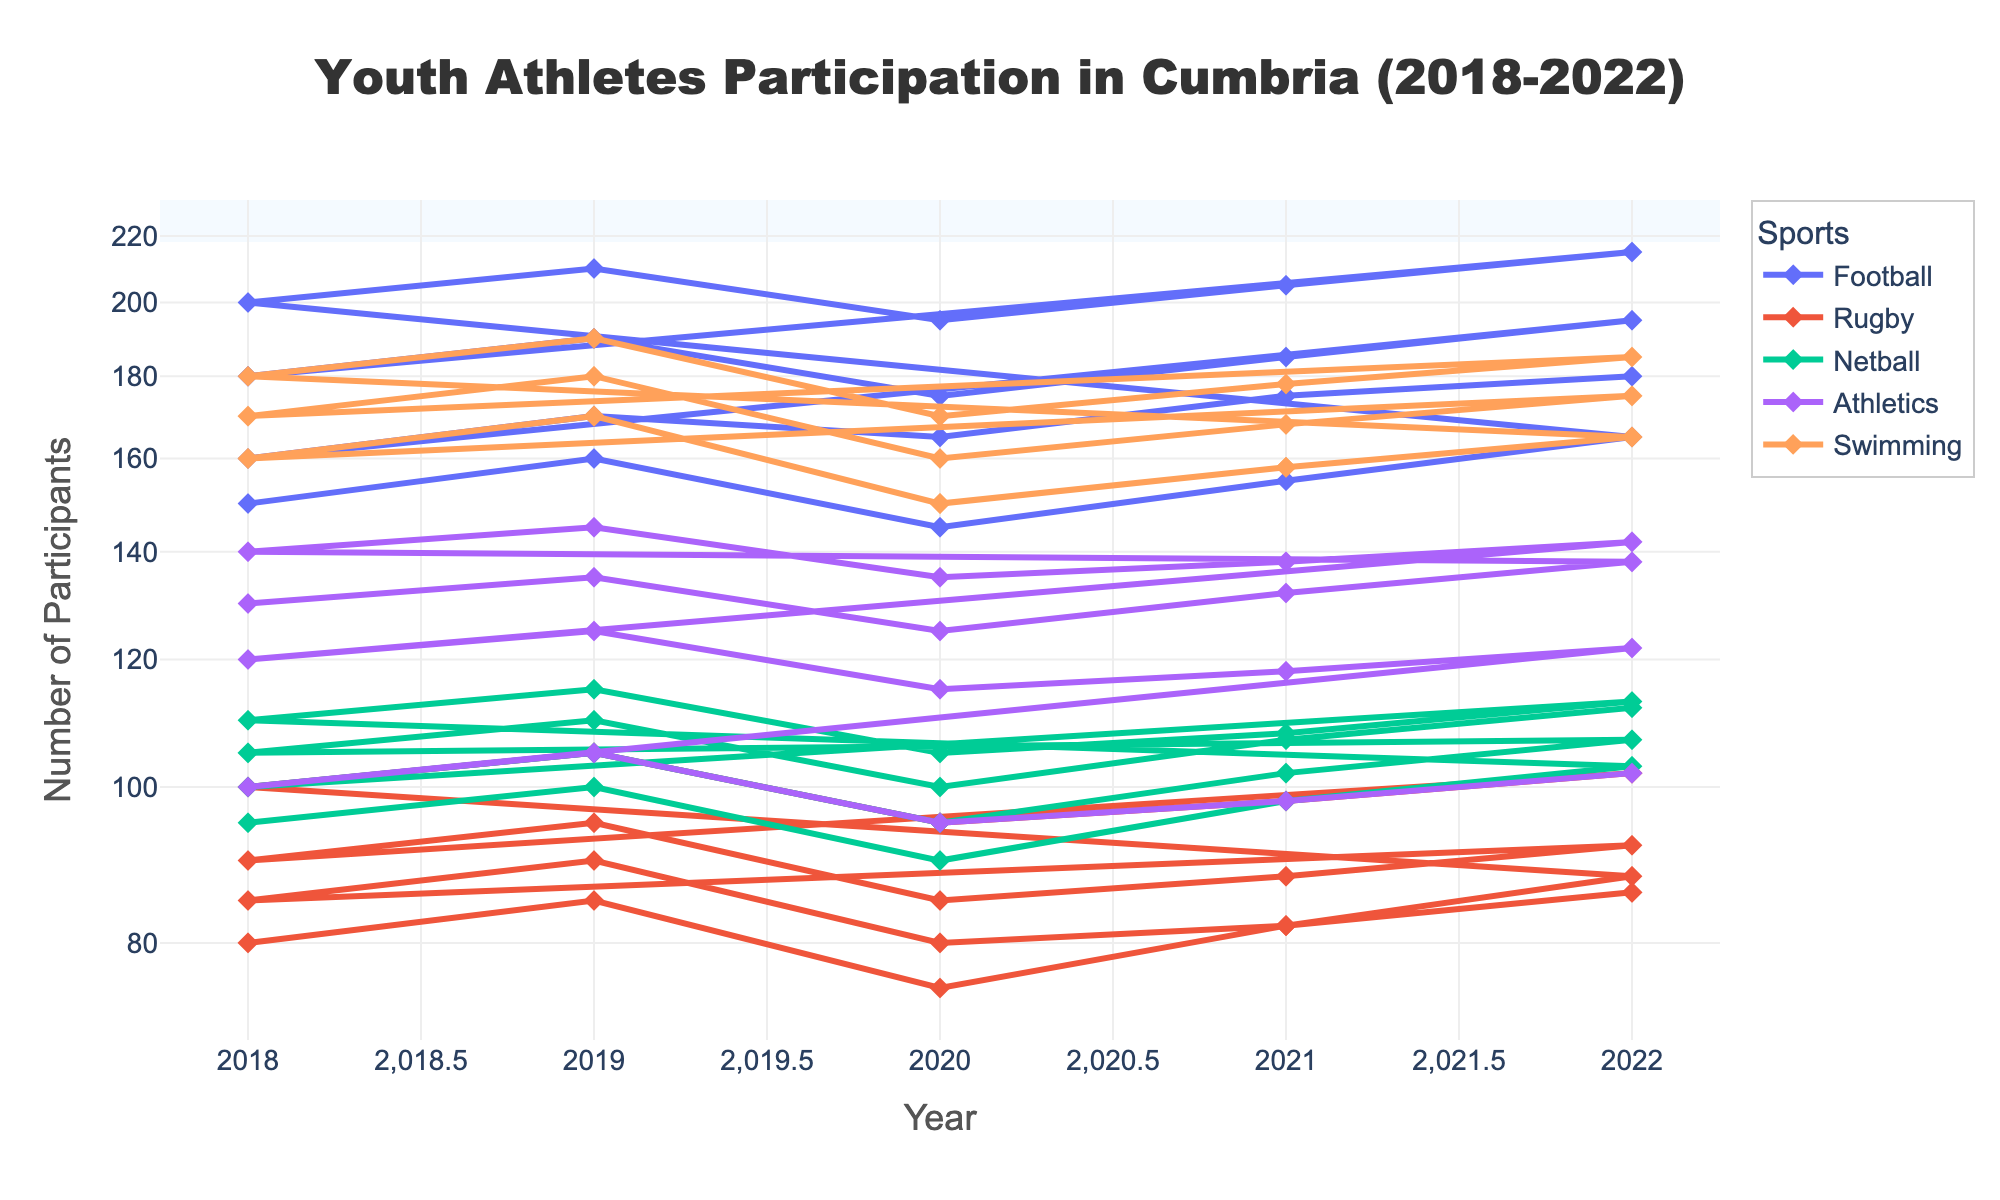What is the title of the figure? The title usually appears at the top of the figure. For this plot, it is intended to provide a summary of the visualized data.
Answer: Youth Athletes Participation in Cumbria (2018-2022) Which sport had the most participants in the "10-12" age group in 2021? Look for the lines representing different sports and focus on the data points for the year 2021 along the x-axis, then identify the highest y-value for the 10-12 age group.
Answer: Football How has the number of participants in athletics for the "16-18" age group changed from 2018 to 2022? Locate the line representing athletics and track its y-values for the "16-18" age group from 2018 to 2022. Compare the starting and ending values.
Answer: Decreased Which sport shows the least variation in participant numbers over the years for the "Under 10" age group? Identify the line for each sport and examine how much the y-values fluctuate for the "Under 10" age group from 2018 to 2022. The sport with the least fluctuation shows the least variation.
Answer: Rugby What is the general trend of participation in netball for the age group "10-12" over the five years? Follow the line representing netball for the "10-12" age group from 2018 to 2022 and observe whether it increases, decreases, or remains stable.
Answer: Increasing In which year did football have the lowest number of participants in the "Under 10" age group? Find the data points for football for the "Under 10" age group for each year and identify the year with the smallest y-value.
Answer: 2020 By how many participants did the "13-15" age group for swimming increase from 2020 to 2022? Look at the data points for swimming in 2020 and 2022 along the y-axis for the "13-15" age group, then subtract the 2020 value from the 2022 value.
Answer: 15 participants Comparing the "10-12" age group, which sport had a higher number of participants in 2020: swimming or rugby? Locate the "10-12" age group data points for swimming and rugby in 2020 and compare their y-values to see which is higher.
Answer: Swimming What is the average number of participants in netball for the "16-18" age group from 2018 to 2022? Sum the y-values for netball for the "16-18" age group from 2018 to 2022 and then divide by the number of years (5).
Answer: 106.8 participants In which age group and year did athletics see a noticeable drop in participation compared to the previous year? Compare y-values between consecutive years for athletics across each age group to identify the most significant drop.
Answer: 13-15 in 2020 